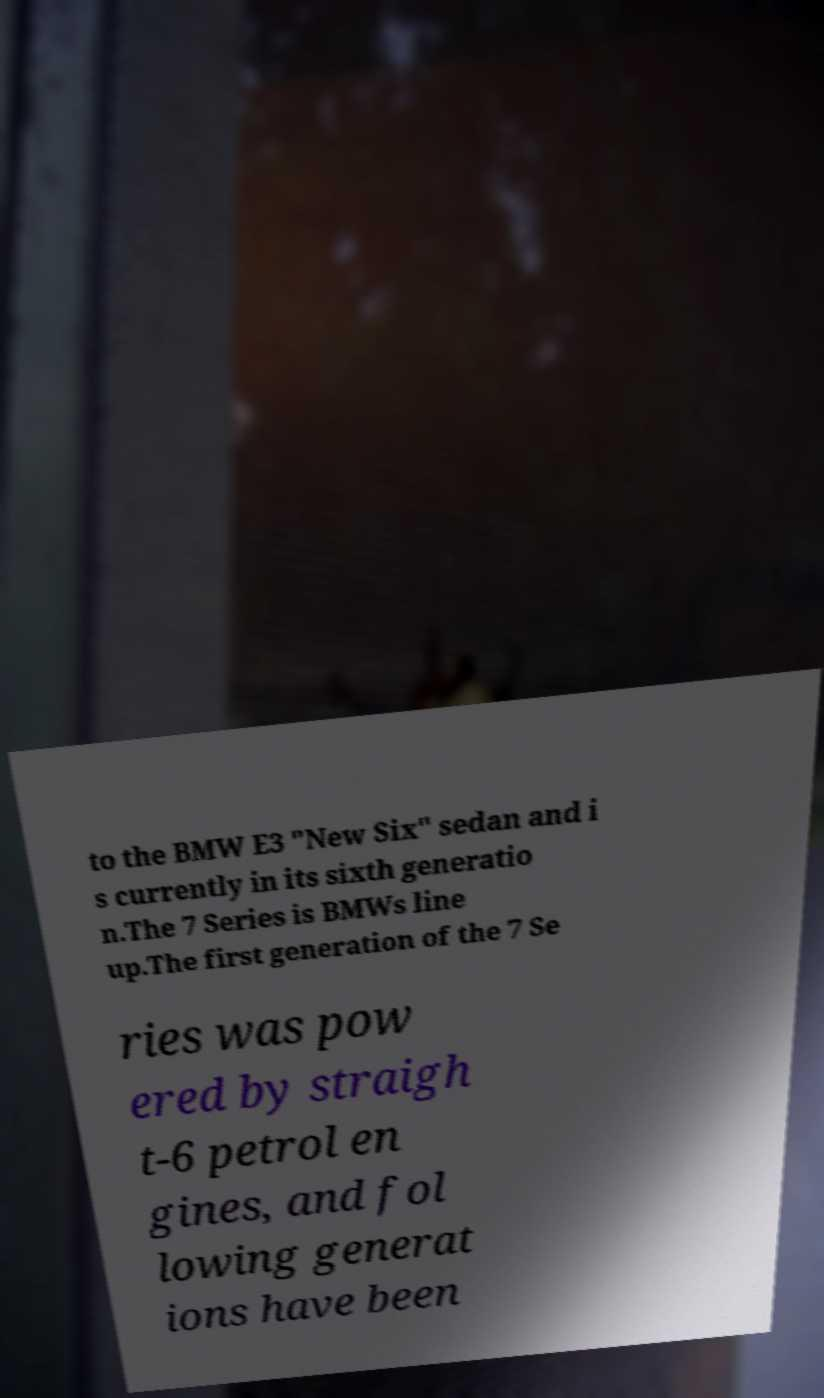Could you assist in decoding the text presented in this image and type it out clearly? to the BMW E3 "New Six" sedan and i s currently in its sixth generatio n.The 7 Series is BMWs line up.The first generation of the 7 Se ries was pow ered by straigh t-6 petrol en gines, and fol lowing generat ions have been 